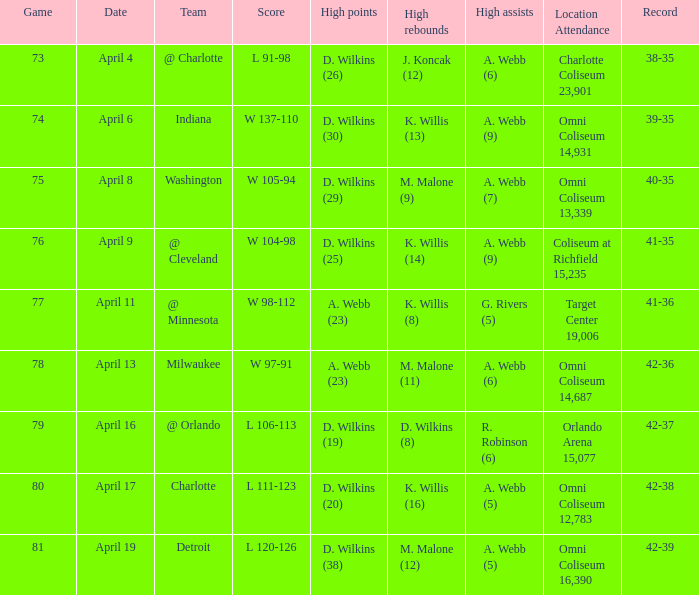What was the location and attendance when d. wilkins (29) had the high points? Omni Coliseum 13,339. 